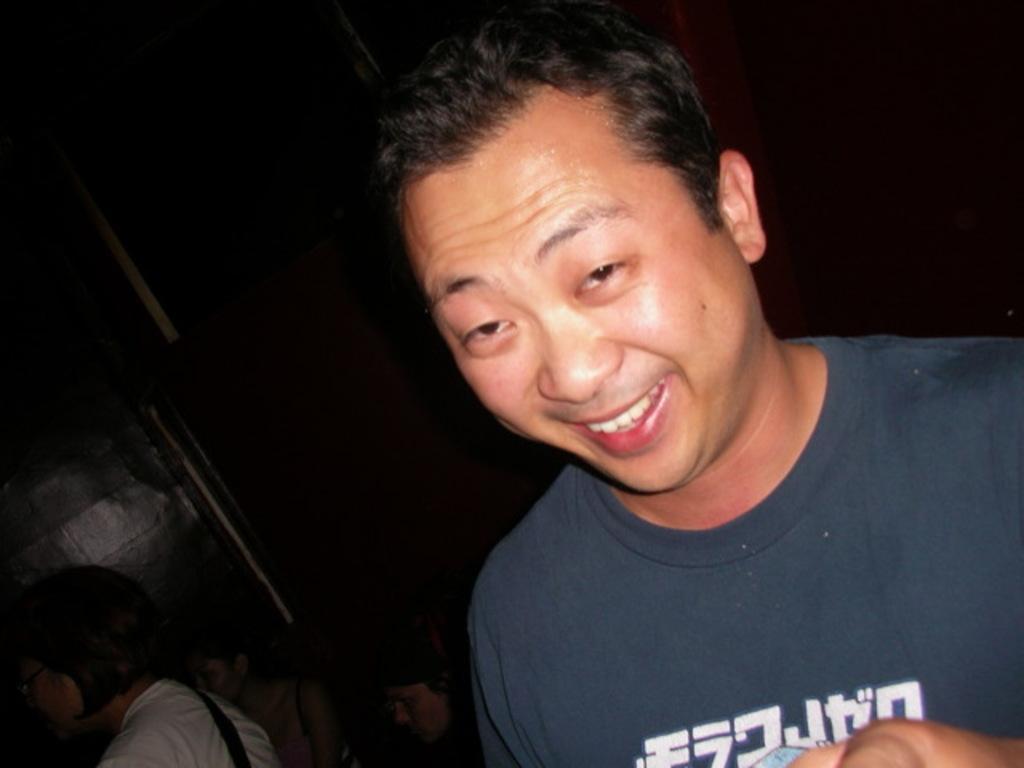How would you summarize this image in a sentence or two? In this image I can see person wearing navy-blue color t-shirt. Background is in black and brown color. I can see few people. 